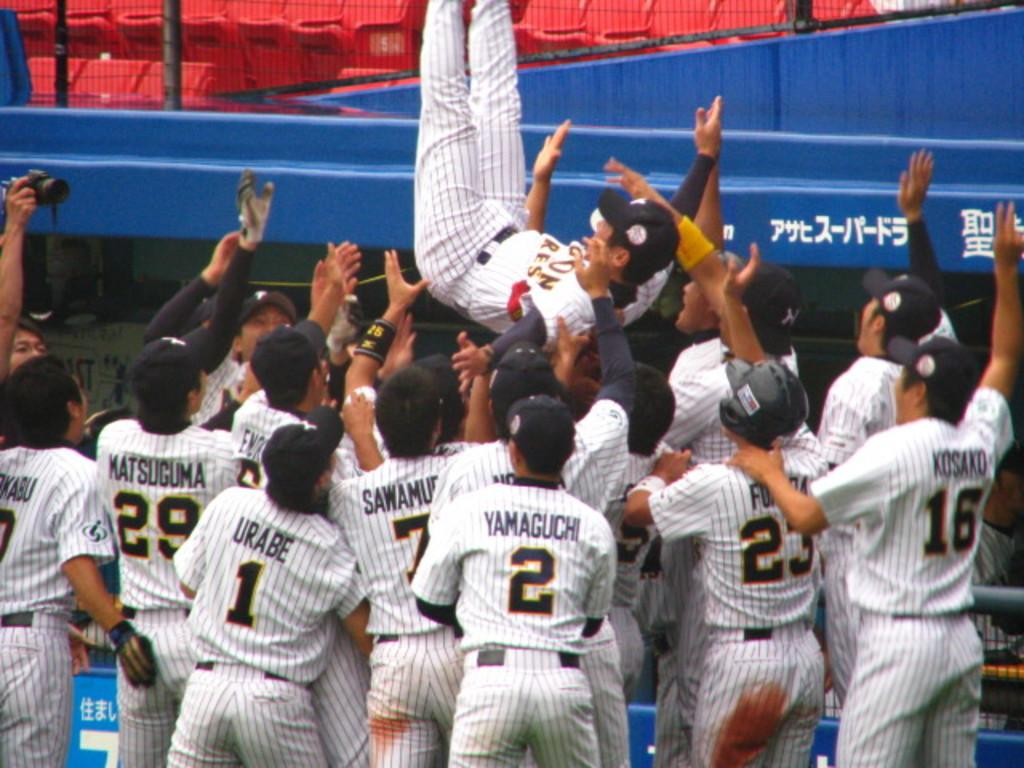Provide a one-sentence caption for the provided image. Baseball players including Matsuguma, Urabe and Yamaguchi celebrate with teammates. 